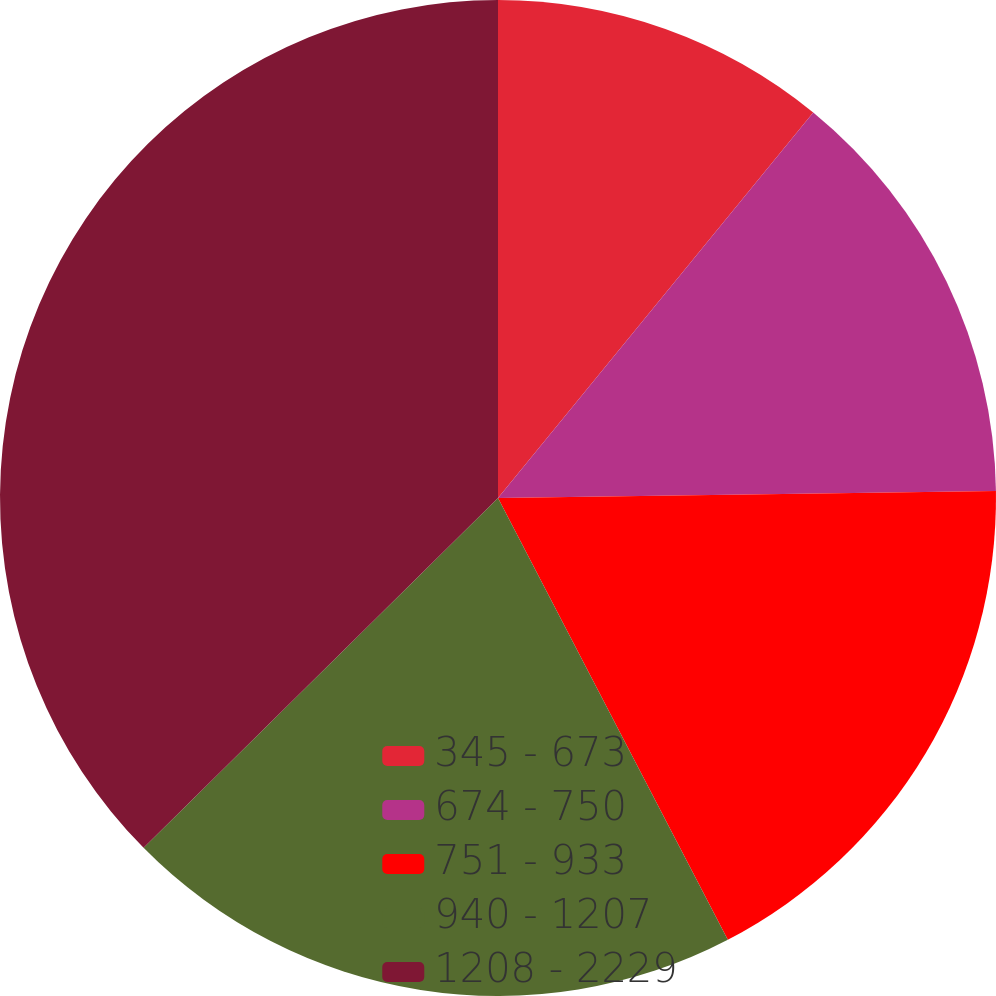<chart> <loc_0><loc_0><loc_500><loc_500><pie_chart><fcel>345 - 673<fcel>674 - 750<fcel>751 - 933<fcel>940 - 1207<fcel>1208 - 2229<nl><fcel>10.91%<fcel>13.87%<fcel>17.59%<fcel>20.24%<fcel>37.4%<nl></chart> 